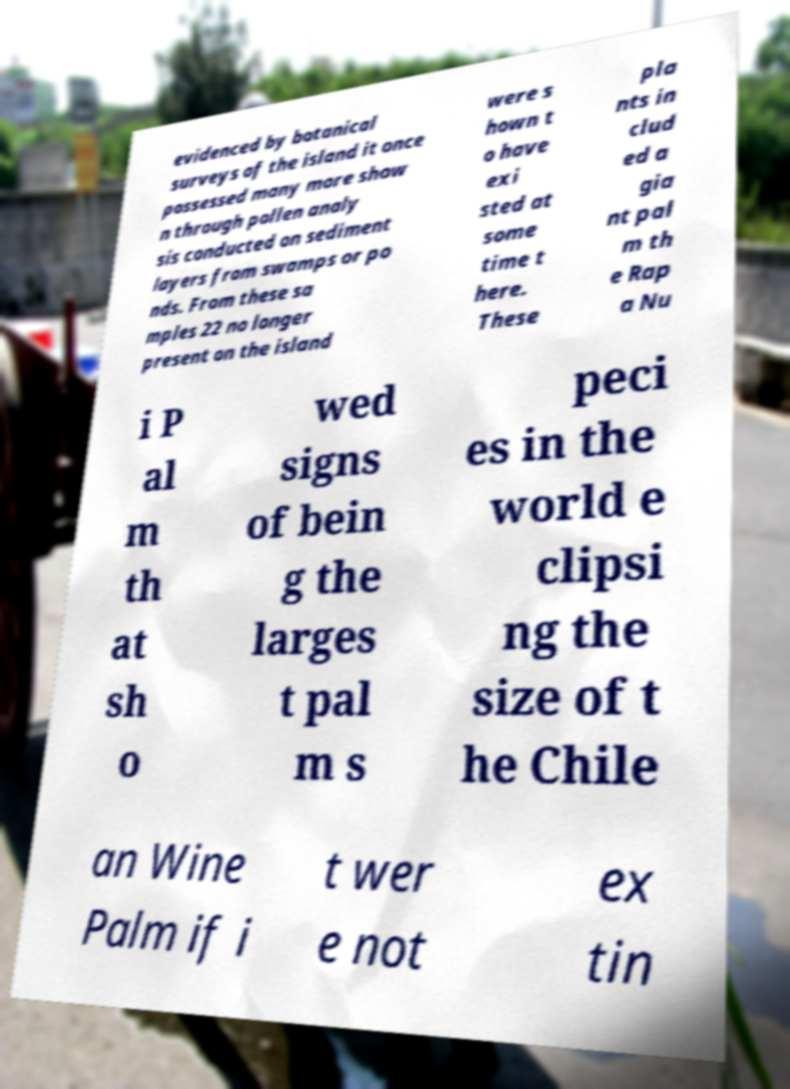Can you accurately transcribe the text from the provided image for me? evidenced by botanical surveys of the island it once possessed many more show n through pollen analy sis conducted on sediment layers from swamps or po nds. From these sa mples 22 no longer present on the island were s hown t o have exi sted at some time t here. These pla nts in clud ed a gia nt pal m th e Rap a Nu i P al m th at sh o wed signs of bein g the larges t pal m s peci es in the world e clipsi ng the size of t he Chile an Wine Palm if i t wer e not ex tin 